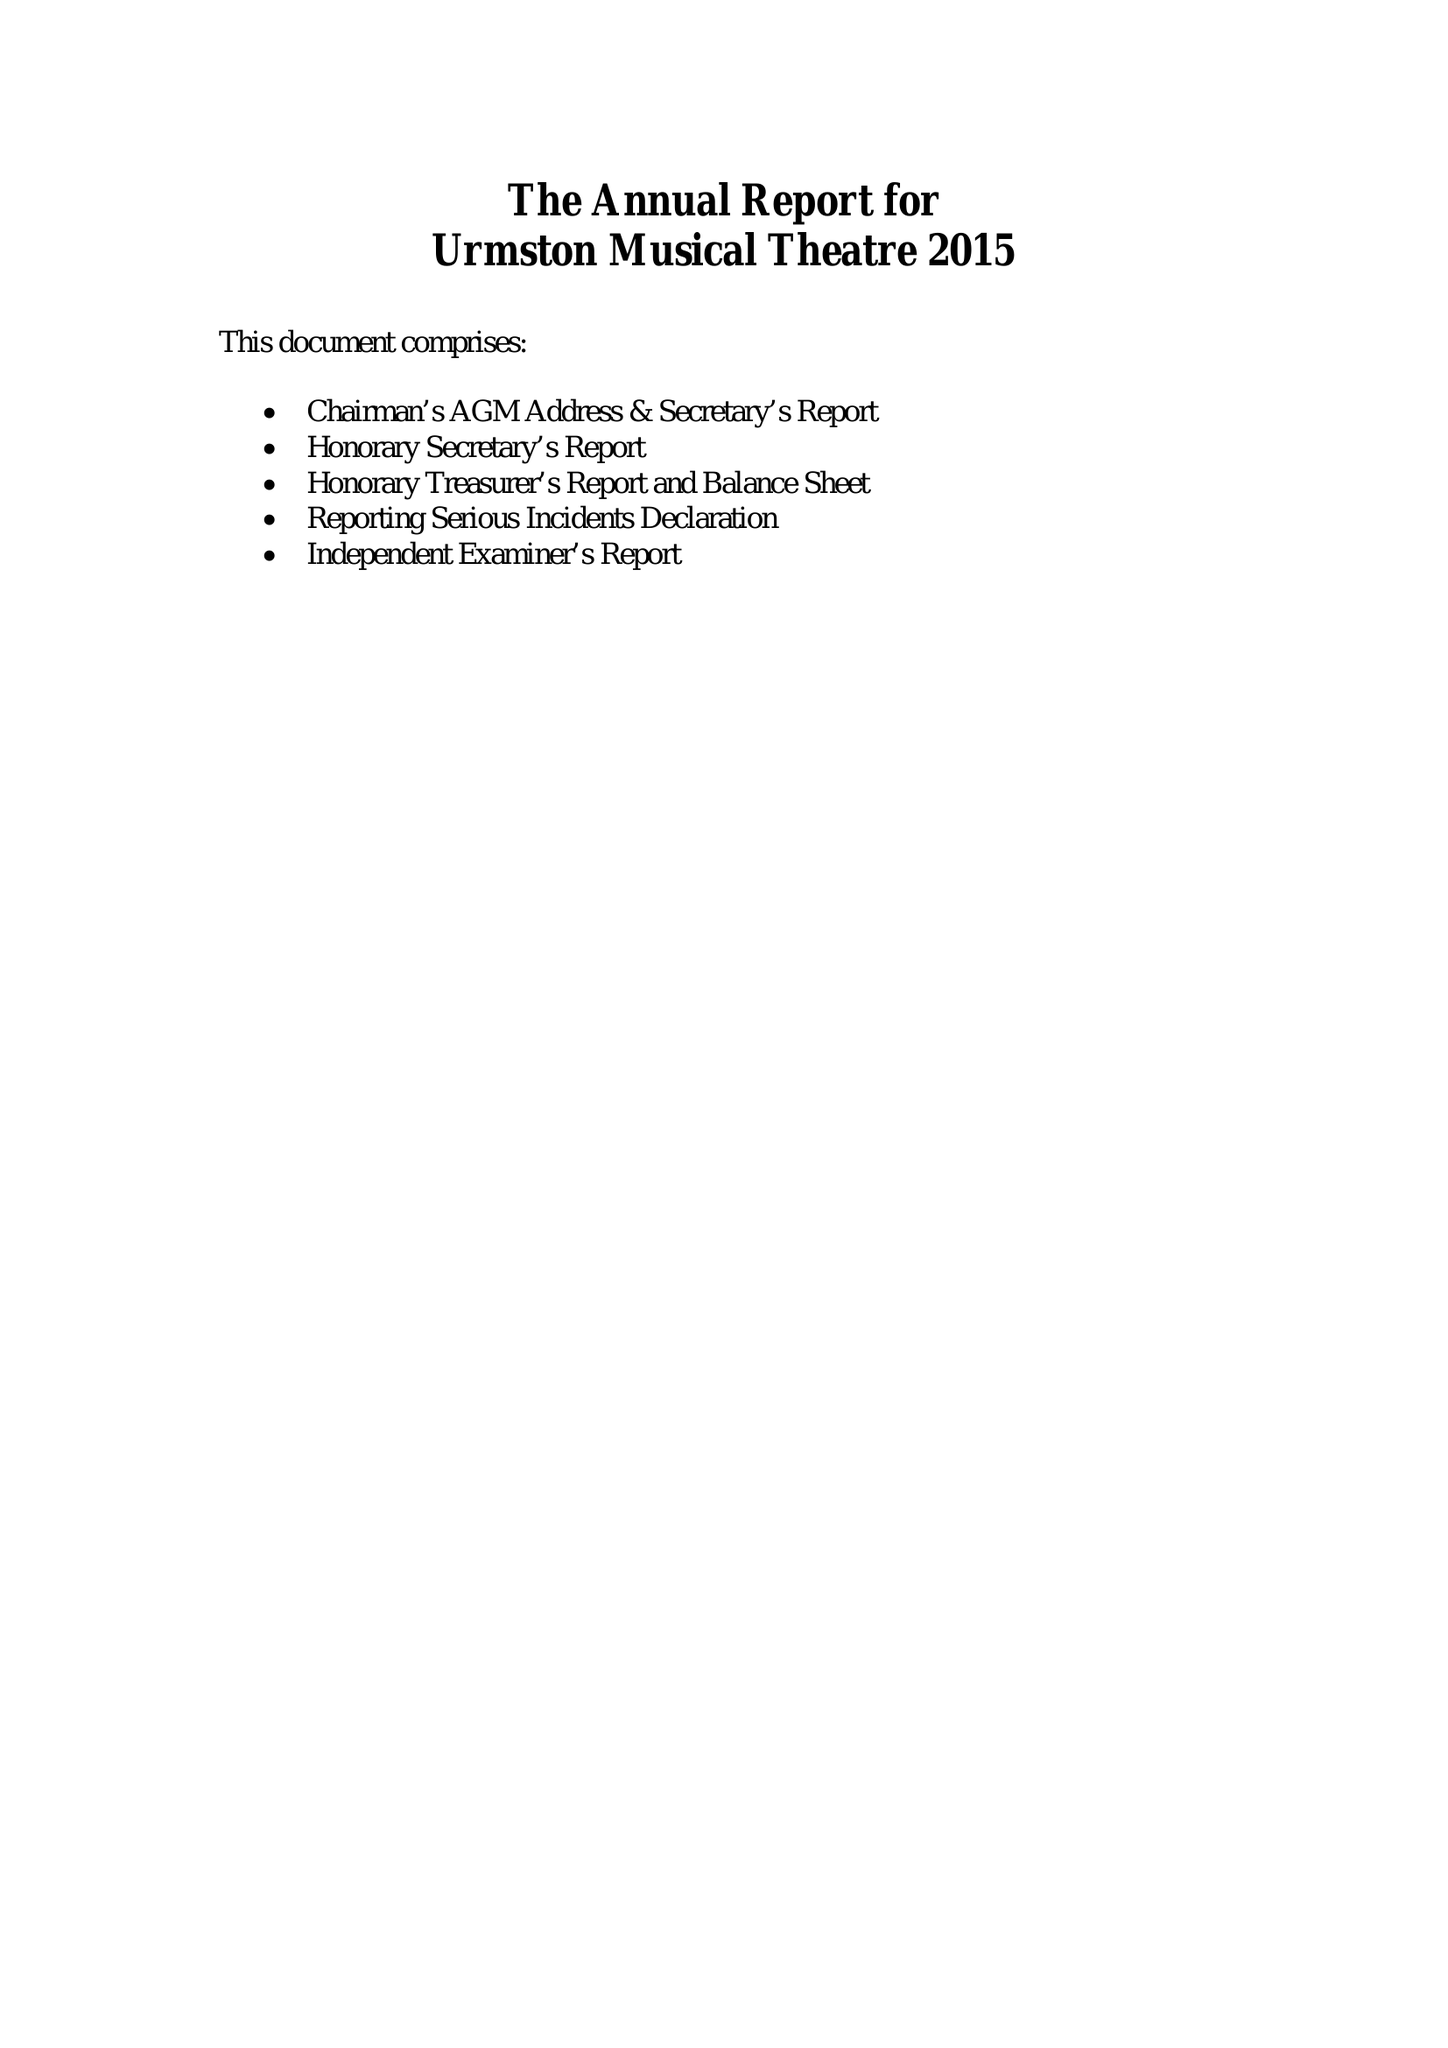What is the value for the address__postcode?
Answer the question using a single word or phrase. M41 5ST 